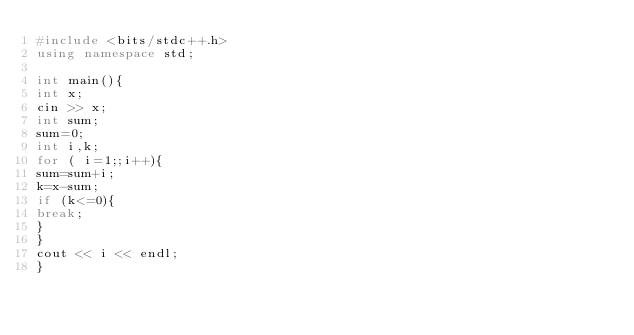Convert code to text. <code><loc_0><loc_0><loc_500><loc_500><_C++_>#include <bits/stdc++.h>
using namespace std;
 
int main(){
int x;
cin >> x;
int sum;
sum=0;
int i,k;
for ( i=1;;i++){
sum=sum+i;
k=x-sum;
if (k<=0){
break;
}
}
cout << i << endl;
}
</code> 